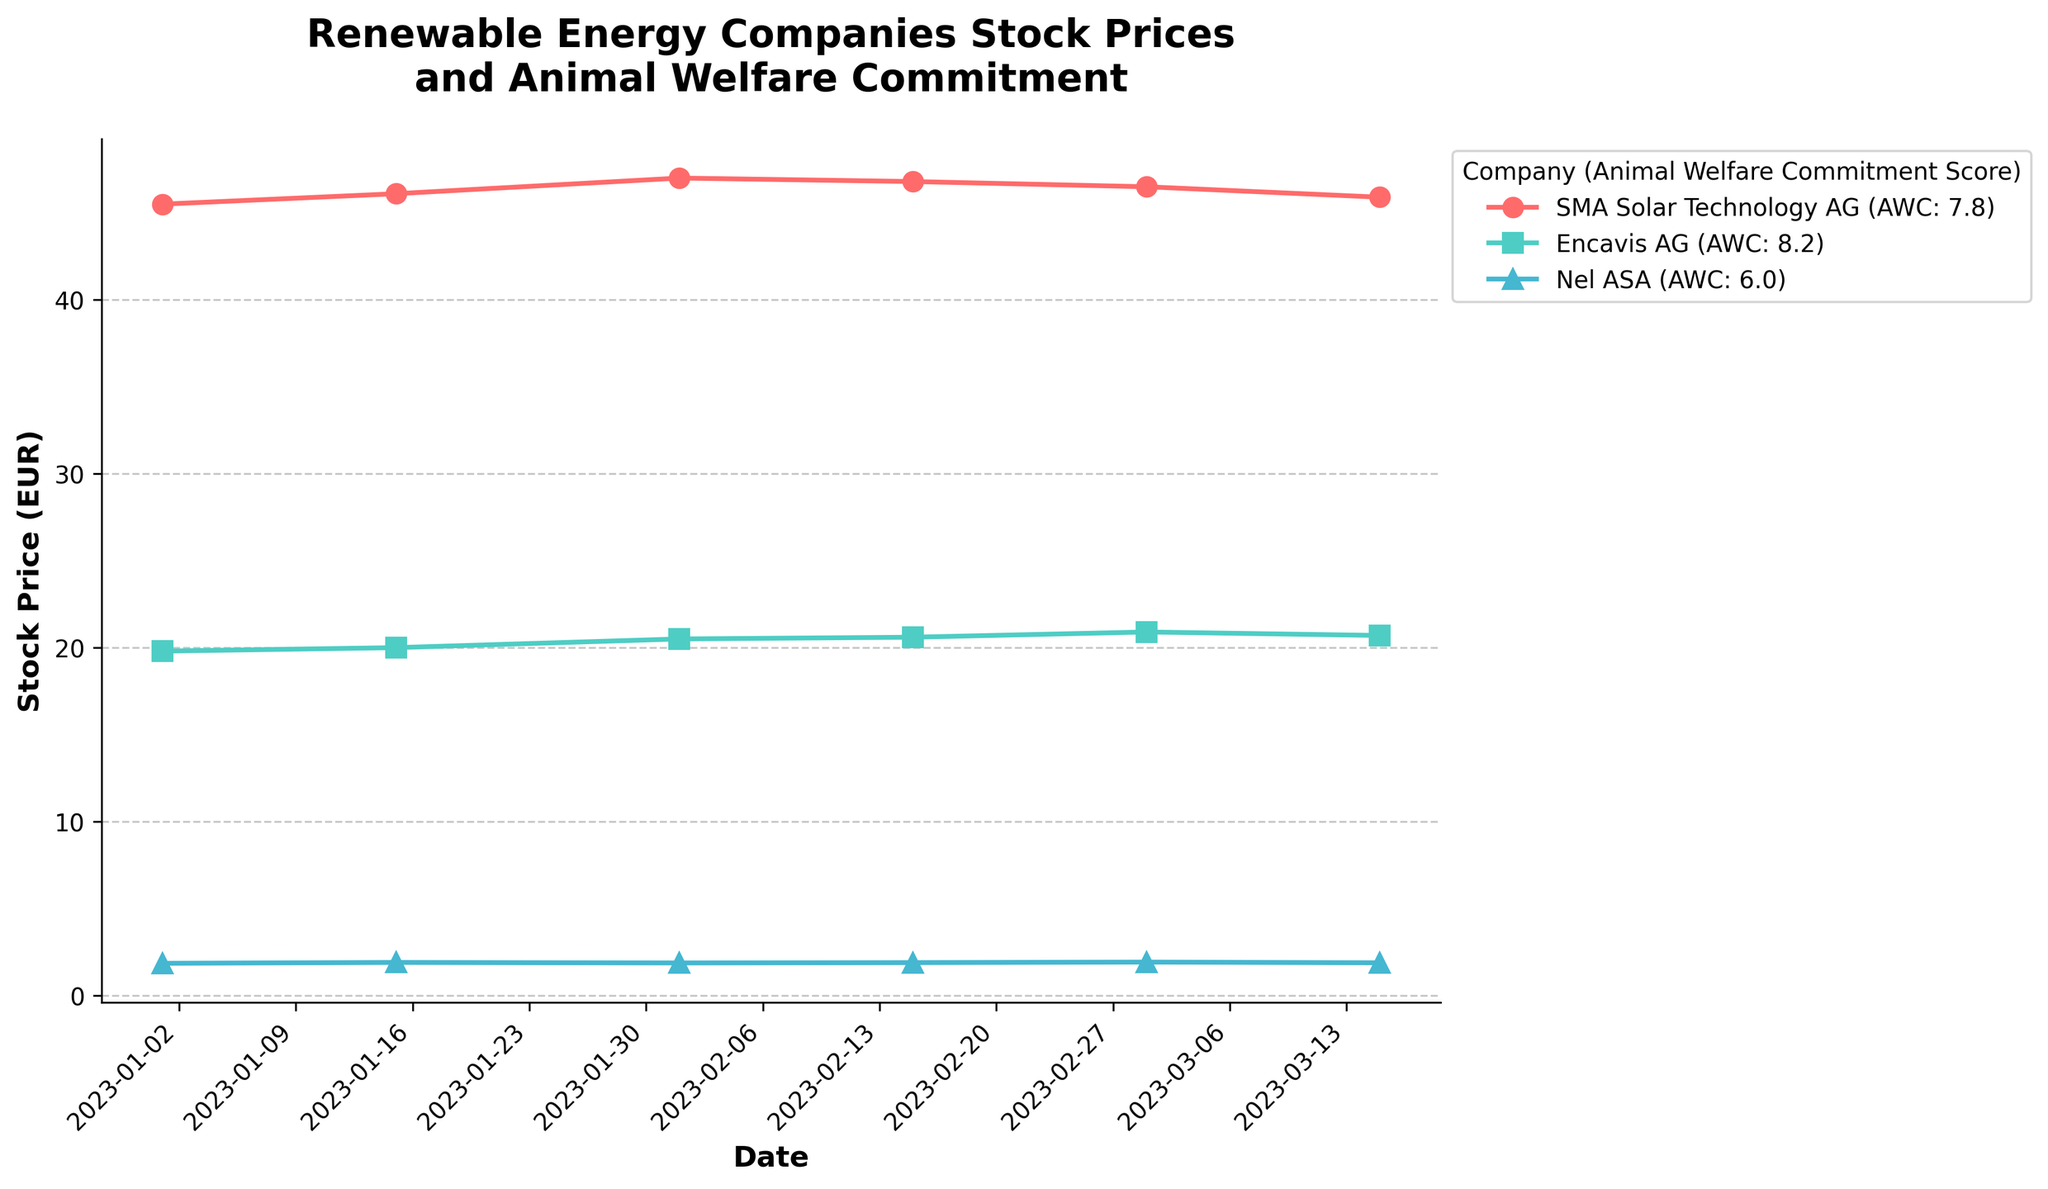What is the title of the figure? The title of the figure is usually displayed at the top. In this case, it reads "Renewable Energy Companies Stock Prices and Animal Welfare Commitment".
Answer: Renewable Energy Companies Stock Prices and Animal Welfare Commitment What is the stock price of SMA Solar Technology AG on 2023-03-01? To find the stock price of SMA Solar Technology AG on 2023-03-01, look at the plotted point for this date. The point is located close to the label for the company and its corresponding marker.
Answer: 46.50 EUR How many companies are represented in the figure? The number of companies is represented by the number of unique labels in the legend. Here, there are three labels with different colors and markers.
Answer: 3 Which company has the highest Animal Welfare Commitment score? Look at the labels in the legend and focus on the Animal Welfare Commitment (AWC) score. The company with the highest AWC score is Encavis AG, with a score of 8.2.
Answer: Encavis AG What is the trend in the stock prices of Nel ASA from January to March 2023? Check the stock price points for Nel ASA across the given dates from January to March. The stock price shows slight fluctuations but generally remains around the same value, indicating minor changes.
Answer: Slight fluctuation, mostly stable How does the stock price of Encavis AG on 2023-02-01 compare to its stock price on 2023-03-01? Locate Encavis AG's stock prices on these two dates. On 2023-02-01, the stock price is 20.50 EUR, and on 2023-03-01, it's 20.90 EUR. The difference is 20.90 - 20.50 = 0.40 EUR increase.
Answer: Increased by 0.40 EUR What is the date when Encavis AG had its highest stock price, and what was the price? Check the stock prices of Encavis AG across all the given dates. The highest price is observed on 2023-03-01 with a value of 20.90 EUR.
Answer: 2023-03-01, 20.90 EUR Which company experienced the largest price drop between any two consecutive dates, and what was the percentage drop? Compare the price drops for each company between consecutive dates. SMA Solar Technology AG had the largest drop from 47.00 to 46.80 EUR (2023-02-01 to 2023-02-15). The percentage drop is calculated as ((47.00 - 46.80) / 47.00) * 100 = 0.43%.
Answer: SMA Solar Technology AG, 0.43% Is there any company whose stock price remained the same over all observed dates? Check the stock prices for each company. If all data points for a company show identical prices, it has remained the same. None of the companies have constant stock prices over the observed dates.
Answer: No How do the stock prices of the three companies compare on 2023-01-15? Evaluate the stock prices on this specific date for all three companies. SMA Solar Technology AG is 46.10 EUR, Encavis AG is 20.00 EUR, and Nel ASA is 1.90 EUR. SMA Solar Technology AG > Encavis AG > Nel ASA.
Answer: SMA Solar Technology AG > Encavis AG > Nel ASA Is there a noticeable correlation between the Animal Welfare Commitment score and the stock price trend for these companies? Check if the companies with higher AWC scores have better stock price trends. Encavis AG has the highest AWC score (8.2) and shows slight positive trend, while SMA Solar Technology AG and Nel ASA, with lower AWC scores, display relatively stable or fluctuating trends. The relationship appears to be loose as stock prices depend on multiple factors not directly shown by the AWC score alone.
Answer: Loose correlation 